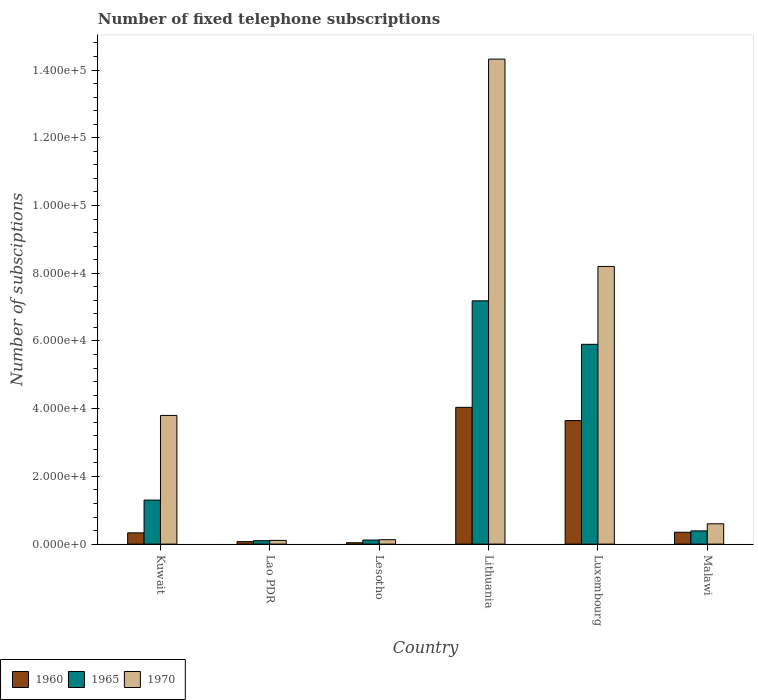How many different coloured bars are there?
Provide a short and direct response. 3. Are the number of bars per tick equal to the number of legend labels?
Your answer should be very brief. Yes. Are the number of bars on each tick of the X-axis equal?
Ensure brevity in your answer.  Yes. How many bars are there on the 6th tick from the right?
Offer a very short reply. 3. What is the label of the 3rd group of bars from the left?
Offer a terse response. Lesotho. What is the number of fixed telephone subscriptions in 1965 in Lao PDR?
Ensure brevity in your answer.  1000. Across all countries, what is the maximum number of fixed telephone subscriptions in 1970?
Your answer should be compact. 1.43e+05. Across all countries, what is the minimum number of fixed telephone subscriptions in 1960?
Ensure brevity in your answer.  400. In which country was the number of fixed telephone subscriptions in 1960 maximum?
Keep it short and to the point. Lithuania. In which country was the number of fixed telephone subscriptions in 1960 minimum?
Offer a terse response. Lesotho. What is the total number of fixed telephone subscriptions in 1960 in the graph?
Give a very brief answer. 8.48e+04. What is the difference between the number of fixed telephone subscriptions in 1960 in Kuwait and that in Malawi?
Your answer should be compact. -184. What is the difference between the number of fixed telephone subscriptions in 1960 in Kuwait and the number of fixed telephone subscriptions in 1970 in Lao PDR?
Give a very brief answer. 2216. What is the average number of fixed telephone subscriptions in 1965 per country?
Provide a short and direct response. 2.50e+04. What is the difference between the number of fixed telephone subscriptions of/in 1965 and number of fixed telephone subscriptions of/in 1970 in Luxembourg?
Keep it short and to the point. -2.30e+04. In how many countries, is the number of fixed telephone subscriptions in 1965 greater than 4000?
Offer a terse response. 3. What is the ratio of the number of fixed telephone subscriptions in 1970 in Lao PDR to that in Lithuania?
Ensure brevity in your answer.  0.01. Is the number of fixed telephone subscriptions in 1960 in Kuwait less than that in Lesotho?
Make the answer very short. No. What is the difference between the highest and the second highest number of fixed telephone subscriptions in 1965?
Provide a short and direct response. 4.60e+04. What is the difference between the highest and the lowest number of fixed telephone subscriptions in 1960?
Provide a short and direct response. 4.00e+04. In how many countries, is the number of fixed telephone subscriptions in 1970 greater than the average number of fixed telephone subscriptions in 1970 taken over all countries?
Provide a succinct answer. 2. Is the sum of the number of fixed telephone subscriptions in 1970 in Kuwait and Luxembourg greater than the maximum number of fixed telephone subscriptions in 1960 across all countries?
Make the answer very short. Yes. What does the 2nd bar from the left in Luxembourg represents?
Your response must be concise. 1965. What does the 1st bar from the right in Kuwait represents?
Offer a very short reply. 1970. Is it the case that in every country, the sum of the number of fixed telephone subscriptions in 1970 and number of fixed telephone subscriptions in 1960 is greater than the number of fixed telephone subscriptions in 1965?
Ensure brevity in your answer.  Yes. Are all the bars in the graph horizontal?
Offer a very short reply. No. Are the values on the major ticks of Y-axis written in scientific E-notation?
Offer a terse response. Yes. Does the graph contain any zero values?
Provide a short and direct response. No. Does the graph contain grids?
Your answer should be very brief. No. How many legend labels are there?
Keep it short and to the point. 3. What is the title of the graph?
Your answer should be very brief. Number of fixed telephone subscriptions. Does "2007" appear as one of the legend labels in the graph?
Your response must be concise. No. What is the label or title of the X-axis?
Ensure brevity in your answer.  Country. What is the label or title of the Y-axis?
Offer a terse response. Number of subsciptions. What is the Number of subsciptions of 1960 in Kuwait?
Provide a short and direct response. 3316. What is the Number of subsciptions of 1965 in Kuwait?
Provide a short and direct response. 1.30e+04. What is the Number of subsciptions of 1970 in Kuwait?
Your response must be concise. 3.80e+04. What is the Number of subsciptions of 1960 in Lao PDR?
Offer a very short reply. 736. What is the Number of subsciptions of 1965 in Lao PDR?
Ensure brevity in your answer.  1000. What is the Number of subsciptions in 1970 in Lao PDR?
Provide a succinct answer. 1100. What is the Number of subsciptions in 1960 in Lesotho?
Your response must be concise. 400. What is the Number of subsciptions of 1965 in Lesotho?
Provide a succinct answer. 1200. What is the Number of subsciptions in 1970 in Lesotho?
Ensure brevity in your answer.  1300. What is the Number of subsciptions of 1960 in Lithuania?
Ensure brevity in your answer.  4.04e+04. What is the Number of subsciptions in 1965 in Lithuania?
Offer a terse response. 7.18e+04. What is the Number of subsciptions of 1970 in Lithuania?
Offer a terse response. 1.43e+05. What is the Number of subsciptions in 1960 in Luxembourg?
Offer a very short reply. 3.65e+04. What is the Number of subsciptions in 1965 in Luxembourg?
Ensure brevity in your answer.  5.90e+04. What is the Number of subsciptions of 1970 in Luxembourg?
Your answer should be very brief. 8.20e+04. What is the Number of subsciptions of 1960 in Malawi?
Your answer should be very brief. 3500. What is the Number of subsciptions of 1965 in Malawi?
Offer a very short reply. 3900. What is the Number of subsciptions of 1970 in Malawi?
Your answer should be compact. 6000. Across all countries, what is the maximum Number of subsciptions in 1960?
Provide a succinct answer. 4.04e+04. Across all countries, what is the maximum Number of subsciptions of 1965?
Provide a short and direct response. 7.18e+04. Across all countries, what is the maximum Number of subsciptions of 1970?
Offer a terse response. 1.43e+05. Across all countries, what is the minimum Number of subsciptions in 1965?
Provide a succinct answer. 1000. Across all countries, what is the minimum Number of subsciptions of 1970?
Keep it short and to the point. 1100. What is the total Number of subsciptions in 1960 in the graph?
Your response must be concise. 8.48e+04. What is the total Number of subsciptions in 1965 in the graph?
Give a very brief answer. 1.50e+05. What is the total Number of subsciptions in 1970 in the graph?
Provide a short and direct response. 2.72e+05. What is the difference between the Number of subsciptions of 1960 in Kuwait and that in Lao PDR?
Offer a very short reply. 2580. What is the difference between the Number of subsciptions in 1965 in Kuwait and that in Lao PDR?
Keep it short and to the point. 1.20e+04. What is the difference between the Number of subsciptions of 1970 in Kuwait and that in Lao PDR?
Provide a short and direct response. 3.69e+04. What is the difference between the Number of subsciptions in 1960 in Kuwait and that in Lesotho?
Make the answer very short. 2916. What is the difference between the Number of subsciptions of 1965 in Kuwait and that in Lesotho?
Offer a terse response. 1.18e+04. What is the difference between the Number of subsciptions in 1970 in Kuwait and that in Lesotho?
Offer a very short reply. 3.67e+04. What is the difference between the Number of subsciptions in 1960 in Kuwait and that in Lithuania?
Your response must be concise. -3.71e+04. What is the difference between the Number of subsciptions of 1965 in Kuwait and that in Lithuania?
Ensure brevity in your answer.  -5.88e+04. What is the difference between the Number of subsciptions of 1970 in Kuwait and that in Lithuania?
Offer a very short reply. -1.05e+05. What is the difference between the Number of subsciptions of 1960 in Kuwait and that in Luxembourg?
Your response must be concise. -3.32e+04. What is the difference between the Number of subsciptions of 1965 in Kuwait and that in Luxembourg?
Give a very brief answer. -4.60e+04. What is the difference between the Number of subsciptions in 1970 in Kuwait and that in Luxembourg?
Ensure brevity in your answer.  -4.40e+04. What is the difference between the Number of subsciptions in 1960 in Kuwait and that in Malawi?
Provide a succinct answer. -184. What is the difference between the Number of subsciptions in 1965 in Kuwait and that in Malawi?
Keep it short and to the point. 9100. What is the difference between the Number of subsciptions in 1970 in Kuwait and that in Malawi?
Offer a terse response. 3.20e+04. What is the difference between the Number of subsciptions in 1960 in Lao PDR and that in Lesotho?
Your response must be concise. 336. What is the difference between the Number of subsciptions of 1965 in Lao PDR and that in Lesotho?
Make the answer very short. -200. What is the difference between the Number of subsciptions in 1970 in Lao PDR and that in Lesotho?
Give a very brief answer. -200. What is the difference between the Number of subsciptions in 1960 in Lao PDR and that in Lithuania?
Your response must be concise. -3.97e+04. What is the difference between the Number of subsciptions of 1965 in Lao PDR and that in Lithuania?
Offer a terse response. -7.08e+04. What is the difference between the Number of subsciptions of 1970 in Lao PDR and that in Lithuania?
Your response must be concise. -1.42e+05. What is the difference between the Number of subsciptions of 1960 in Lao PDR and that in Luxembourg?
Keep it short and to the point. -3.58e+04. What is the difference between the Number of subsciptions of 1965 in Lao PDR and that in Luxembourg?
Your answer should be very brief. -5.80e+04. What is the difference between the Number of subsciptions in 1970 in Lao PDR and that in Luxembourg?
Your response must be concise. -8.09e+04. What is the difference between the Number of subsciptions of 1960 in Lao PDR and that in Malawi?
Give a very brief answer. -2764. What is the difference between the Number of subsciptions of 1965 in Lao PDR and that in Malawi?
Provide a succinct answer. -2900. What is the difference between the Number of subsciptions in 1970 in Lao PDR and that in Malawi?
Make the answer very short. -4900. What is the difference between the Number of subsciptions in 1960 in Lesotho and that in Lithuania?
Offer a very short reply. -4.00e+04. What is the difference between the Number of subsciptions of 1965 in Lesotho and that in Lithuania?
Your answer should be very brief. -7.06e+04. What is the difference between the Number of subsciptions of 1970 in Lesotho and that in Lithuania?
Your response must be concise. -1.42e+05. What is the difference between the Number of subsciptions of 1960 in Lesotho and that in Luxembourg?
Provide a succinct answer. -3.61e+04. What is the difference between the Number of subsciptions in 1965 in Lesotho and that in Luxembourg?
Keep it short and to the point. -5.78e+04. What is the difference between the Number of subsciptions in 1970 in Lesotho and that in Luxembourg?
Provide a succinct answer. -8.07e+04. What is the difference between the Number of subsciptions of 1960 in Lesotho and that in Malawi?
Your answer should be compact. -3100. What is the difference between the Number of subsciptions in 1965 in Lesotho and that in Malawi?
Your response must be concise. -2700. What is the difference between the Number of subsciptions of 1970 in Lesotho and that in Malawi?
Make the answer very short. -4700. What is the difference between the Number of subsciptions in 1960 in Lithuania and that in Luxembourg?
Your answer should be very brief. 3902. What is the difference between the Number of subsciptions of 1965 in Lithuania and that in Luxembourg?
Your response must be concise. 1.28e+04. What is the difference between the Number of subsciptions in 1970 in Lithuania and that in Luxembourg?
Offer a terse response. 6.12e+04. What is the difference between the Number of subsciptions of 1960 in Lithuania and that in Malawi?
Make the answer very short. 3.69e+04. What is the difference between the Number of subsciptions in 1965 in Lithuania and that in Malawi?
Your response must be concise. 6.79e+04. What is the difference between the Number of subsciptions in 1970 in Lithuania and that in Malawi?
Ensure brevity in your answer.  1.37e+05. What is the difference between the Number of subsciptions in 1960 in Luxembourg and that in Malawi?
Offer a very short reply. 3.30e+04. What is the difference between the Number of subsciptions in 1965 in Luxembourg and that in Malawi?
Provide a succinct answer. 5.51e+04. What is the difference between the Number of subsciptions of 1970 in Luxembourg and that in Malawi?
Provide a short and direct response. 7.60e+04. What is the difference between the Number of subsciptions of 1960 in Kuwait and the Number of subsciptions of 1965 in Lao PDR?
Your answer should be very brief. 2316. What is the difference between the Number of subsciptions in 1960 in Kuwait and the Number of subsciptions in 1970 in Lao PDR?
Ensure brevity in your answer.  2216. What is the difference between the Number of subsciptions of 1965 in Kuwait and the Number of subsciptions of 1970 in Lao PDR?
Your answer should be very brief. 1.19e+04. What is the difference between the Number of subsciptions in 1960 in Kuwait and the Number of subsciptions in 1965 in Lesotho?
Your response must be concise. 2116. What is the difference between the Number of subsciptions in 1960 in Kuwait and the Number of subsciptions in 1970 in Lesotho?
Keep it short and to the point. 2016. What is the difference between the Number of subsciptions in 1965 in Kuwait and the Number of subsciptions in 1970 in Lesotho?
Offer a very short reply. 1.17e+04. What is the difference between the Number of subsciptions of 1960 in Kuwait and the Number of subsciptions of 1965 in Lithuania?
Provide a succinct answer. -6.85e+04. What is the difference between the Number of subsciptions of 1960 in Kuwait and the Number of subsciptions of 1970 in Lithuania?
Make the answer very short. -1.40e+05. What is the difference between the Number of subsciptions in 1965 in Kuwait and the Number of subsciptions in 1970 in Lithuania?
Offer a terse response. -1.30e+05. What is the difference between the Number of subsciptions in 1960 in Kuwait and the Number of subsciptions in 1965 in Luxembourg?
Make the answer very short. -5.57e+04. What is the difference between the Number of subsciptions of 1960 in Kuwait and the Number of subsciptions of 1970 in Luxembourg?
Provide a short and direct response. -7.87e+04. What is the difference between the Number of subsciptions of 1965 in Kuwait and the Number of subsciptions of 1970 in Luxembourg?
Your answer should be compact. -6.90e+04. What is the difference between the Number of subsciptions of 1960 in Kuwait and the Number of subsciptions of 1965 in Malawi?
Give a very brief answer. -584. What is the difference between the Number of subsciptions of 1960 in Kuwait and the Number of subsciptions of 1970 in Malawi?
Offer a terse response. -2684. What is the difference between the Number of subsciptions in 1965 in Kuwait and the Number of subsciptions in 1970 in Malawi?
Offer a terse response. 7000. What is the difference between the Number of subsciptions of 1960 in Lao PDR and the Number of subsciptions of 1965 in Lesotho?
Offer a very short reply. -464. What is the difference between the Number of subsciptions of 1960 in Lao PDR and the Number of subsciptions of 1970 in Lesotho?
Your response must be concise. -564. What is the difference between the Number of subsciptions of 1965 in Lao PDR and the Number of subsciptions of 1970 in Lesotho?
Ensure brevity in your answer.  -300. What is the difference between the Number of subsciptions of 1960 in Lao PDR and the Number of subsciptions of 1965 in Lithuania?
Offer a terse response. -7.11e+04. What is the difference between the Number of subsciptions in 1960 in Lao PDR and the Number of subsciptions in 1970 in Lithuania?
Keep it short and to the point. -1.42e+05. What is the difference between the Number of subsciptions in 1965 in Lao PDR and the Number of subsciptions in 1970 in Lithuania?
Your answer should be compact. -1.42e+05. What is the difference between the Number of subsciptions in 1960 in Lao PDR and the Number of subsciptions in 1965 in Luxembourg?
Offer a very short reply. -5.83e+04. What is the difference between the Number of subsciptions in 1960 in Lao PDR and the Number of subsciptions in 1970 in Luxembourg?
Provide a succinct answer. -8.13e+04. What is the difference between the Number of subsciptions of 1965 in Lao PDR and the Number of subsciptions of 1970 in Luxembourg?
Your answer should be very brief. -8.10e+04. What is the difference between the Number of subsciptions of 1960 in Lao PDR and the Number of subsciptions of 1965 in Malawi?
Give a very brief answer. -3164. What is the difference between the Number of subsciptions of 1960 in Lao PDR and the Number of subsciptions of 1970 in Malawi?
Give a very brief answer. -5264. What is the difference between the Number of subsciptions in 1965 in Lao PDR and the Number of subsciptions in 1970 in Malawi?
Your response must be concise. -5000. What is the difference between the Number of subsciptions of 1960 in Lesotho and the Number of subsciptions of 1965 in Lithuania?
Keep it short and to the point. -7.14e+04. What is the difference between the Number of subsciptions of 1960 in Lesotho and the Number of subsciptions of 1970 in Lithuania?
Ensure brevity in your answer.  -1.43e+05. What is the difference between the Number of subsciptions in 1965 in Lesotho and the Number of subsciptions in 1970 in Lithuania?
Your answer should be compact. -1.42e+05. What is the difference between the Number of subsciptions of 1960 in Lesotho and the Number of subsciptions of 1965 in Luxembourg?
Ensure brevity in your answer.  -5.86e+04. What is the difference between the Number of subsciptions in 1960 in Lesotho and the Number of subsciptions in 1970 in Luxembourg?
Give a very brief answer. -8.16e+04. What is the difference between the Number of subsciptions in 1965 in Lesotho and the Number of subsciptions in 1970 in Luxembourg?
Ensure brevity in your answer.  -8.08e+04. What is the difference between the Number of subsciptions in 1960 in Lesotho and the Number of subsciptions in 1965 in Malawi?
Make the answer very short. -3500. What is the difference between the Number of subsciptions of 1960 in Lesotho and the Number of subsciptions of 1970 in Malawi?
Make the answer very short. -5600. What is the difference between the Number of subsciptions of 1965 in Lesotho and the Number of subsciptions of 1970 in Malawi?
Make the answer very short. -4800. What is the difference between the Number of subsciptions of 1960 in Lithuania and the Number of subsciptions of 1965 in Luxembourg?
Your answer should be compact. -1.86e+04. What is the difference between the Number of subsciptions in 1960 in Lithuania and the Number of subsciptions in 1970 in Luxembourg?
Your answer should be compact. -4.16e+04. What is the difference between the Number of subsciptions of 1965 in Lithuania and the Number of subsciptions of 1970 in Luxembourg?
Your answer should be compact. -1.02e+04. What is the difference between the Number of subsciptions of 1960 in Lithuania and the Number of subsciptions of 1965 in Malawi?
Give a very brief answer. 3.65e+04. What is the difference between the Number of subsciptions of 1960 in Lithuania and the Number of subsciptions of 1970 in Malawi?
Make the answer very short. 3.44e+04. What is the difference between the Number of subsciptions of 1965 in Lithuania and the Number of subsciptions of 1970 in Malawi?
Make the answer very short. 6.58e+04. What is the difference between the Number of subsciptions of 1960 in Luxembourg and the Number of subsciptions of 1965 in Malawi?
Provide a short and direct response. 3.26e+04. What is the difference between the Number of subsciptions of 1960 in Luxembourg and the Number of subsciptions of 1970 in Malawi?
Your answer should be very brief. 3.05e+04. What is the difference between the Number of subsciptions of 1965 in Luxembourg and the Number of subsciptions of 1970 in Malawi?
Ensure brevity in your answer.  5.30e+04. What is the average Number of subsciptions of 1960 per country?
Your answer should be compact. 1.41e+04. What is the average Number of subsciptions in 1965 per country?
Offer a terse response. 2.50e+04. What is the average Number of subsciptions of 1970 per country?
Ensure brevity in your answer.  4.53e+04. What is the difference between the Number of subsciptions in 1960 and Number of subsciptions in 1965 in Kuwait?
Your answer should be compact. -9684. What is the difference between the Number of subsciptions of 1960 and Number of subsciptions of 1970 in Kuwait?
Offer a terse response. -3.47e+04. What is the difference between the Number of subsciptions in 1965 and Number of subsciptions in 1970 in Kuwait?
Give a very brief answer. -2.50e+04. What is the difference between the Number of subsciptions in 1960 and Number of subsciptions in 1965 in Lao PDR?
Your answer should be compact. -264. What is the difference between the Number of subsciptions of 1960 and Number of subsciptions of 1970 in Lao PDR?
Provide a succinct answer. -364. What is the difference between the Number of subsciptions in 1965 and Number of subsciptions in 1970 in Lao PDR?
Your answer should be compact. -100. What is the difference between the Number of subsciptions of 1960 and Number of subsciptions of 1965 in Lesotho?
Your answer should be very brief. -800. What is the difference between the Number of subsciptions of 1960 and Number of subsciptions of 1970 in Lesotho?
Your answer should be very brief. -900. What is the difference between the Number of subsciptions in 1965 and Number of subsciptions in 1970 in Lesotho?
Keep it short and to the point. -100. What is the difference between the Number of subsciptions of 1960 and Number of subsciptions of 1965 in Lithuania?
Provide a succinct answer. -3.15e+04. What is the difference between the Number of subsciptions of 1960 and Number of subsciptions of 1970 in Lithuania?
Your answer should be compact. -1.03e+05. What is the difference between the Number of subsciptions of 1965 and Number of subsciptions of 1970 in Lithuania?
Keep it short and to the point. -7.14e+04. What is the difference between the Number of subsciptions in 1960 and Number of subsciptions in 1965 in Luxembourg?
Your answer should be compact. -2.25e+04. What is the difference between the Number of subsciptions in 1960 and Number of subsciptions in 1970 in Luxembourg?
Provide a succinct answer. -4.55e+04. What is the difference between the Number of subsciptions in 1965 and Number of subsciptions in 1970 in Luxembourg?
Your response must be concise. -2.30e+04. What is the difference between the Number of subsciptions in 1960 and Number of subsciptions in 1965 in Malawi?
Keep it short and to the point. -400. What is the difference between the Number of subsciptions in 1960 and Number of subsciptions in 1970 in Malawi?
Give a very brief answer. -2500. What is the difference between the Number of subsciptions in 1965 and Number of subsciptions in 1970 in Malawi?
Offer a terse response. -2100. What is the ratio of the Number of subsciptions in 1960 in Kuwait to that in Lao PDR?
Your answer should be very brief. 4.51. What is the ratio of the Number of subsciptions in 1970 in Kuwait to that in Lao PDR?
Your response must be concise. 34.55. What is the ratio of the Number of subsciptions of 1960 in Kuwait to that in Lesotho?
Offer a very short reply. 8.29. What is the ratio of the Number of subsciptions in 1965 in Kuwait to that in Lesotho?
Provide a succinct answer. 10.83. What is the ratio of the Number of subsciptions of 1970 in Kuwait to that in Lesotho?
Ensure brevity in your answer.  29.23. What is the ratio of the Number of subsciptions in 1960 in Kuwait to that in Lithuania?
Your response must be concise. 0.08. What is the ratio of the Number of subsciptions in 1965 in Kuwait to that in Lithuania?
Ensure brevity in your answer.  0.18. What is the ratio of the Number of subsciptions of 1970 in Kuwait to that in Lithuania?
Ensure brevity in your answer.  0.27. What is the ratio of the Number of subsciptions in 1960 in Kuwait to that in Luxembourg?
Provide a succinct answer. 0.09. What is the ratio of the Number of subsciptions in 1965 in Kuwait to that in Luxembourg?
Your response must be concise. 0.22. What is the ratio of the Number of subsciptions of 1970 in Kuwait to that in Luxembourg?
Keep it short and to the point. 0.46. What is the ratio of the Number of subsciptions of 1960 in Kuwait to that in Malawi?
Offer a very short reply. 0.95. What is the ratio of the Number of subsciptions in 1970 in Kuwait to that in Malawi?
Ensure brevity in your answer.  6.33. What is the ratio of the Number of subsciptions in 1960 in Lao PDR to that in Lesotho?
Your response must be concise. 1.84. What is the ratio of the Number of subsciptions in 1965 in Lao PDR to that in Lesotho?
Keep it short and to the point. 0.83. What is the ratio of the Number of subsciptions in 1970 in Lao PDR to that in Lesotho?
Your response must be concise. 0.85. What is the ratio of the Number of subsciptions in 1960 in Lao PDR to that in Lithuania?
Make the answer very short. 0.02. What is the ratio of the Number of subsciptions of 1965 in Lao PDR to that in Lithuania?
Keep it short and to the point. 0.01. What is the ratio of the Number of subsciptions in 1970 in Lao PDR to that in Lithuania?
Ensure brevity in your answer.  0.01. What is the ratio of the Number of subsciptions in 1960 in Lao PDR to that in Luxembourg?
Keep it short and to the point. 0.02. What is the ratio of the Number of subsciptions of 1965 in Lao PDR to that in Luxembourg?
Offer a very short reply. 0.02. What is the ratio of the Number of subsciptions of 1970 in Lao PDR to that in Luxembourg?
Your response must be concise. 0.01. What is the ratio of the Number of subsciptions in 1960 in Lao PDR to that in Malawi?
Offer a very short reply. 0.21. What is the ratio of the Number of subsciptions of 1965 in Lao PDR to that in Malawi?
Make the answer very short. 0.26. What is the ratio of the Number of subsciptions in 1970 in Lao PDR to that in Malawi?
Offer a very short reply. 0.18. What is the ratio of the Number of subsciptions of 1960 in Lesotho to that in Lithuania?
Your answer should be very brief. 0.01. What is the ratio of the Number of subsciptions of 1965 in Lesotho to that in Lithuania?
Provide a short and direct response. 0.02. What is the ratio of the Number of subsciptions of 1970 in Lesotho to that in Lithuania?
Your answer should be compact. 0.01. What is the ratio of the Number of subsciptions of 1960 in Lesotho to that in Luxembourg?
Provide a short and direct response. 0.01. What is the ratio of the Number of subsciptions in 1965 in Lesotho to that in Luxembourg?
Your response must be concise. 0.02. What is the ratio of the Number of subsciptions in 1970 in Lesotho to that in Luxembourg?
Offer a very short reply. 0.02. What is the ratio of the Number of subsciptions in 1960 in Lesotho to that in Malawi?
Your response must be concise. 0.11. What is the ratio of the Number of subsciptions of 1965 in Lesotho to that in Malawi?
Provide a succinct answer. 0.31. What is the ratio of the Number of subsciptions of 1970 in Lesotho to that in Malawi?
Offer a very short reply. 0.22. What is the ratio of the Number of subsciptions of 1960 in Lithuania to that in Luxembourg?
Your response must be concise. 1.11. What is the ratio of the Number of subsciptions of 1965 in Lithuania to that in Luxembourg?
Ensure brevity in your answer.  1.22. What is the ratio of the Number of subsciptions in 1970 in Lithuania to that in Luxembourg?
Your response must be concise. 1.75. What is the ratio of the Number of subsciptions of 1960 in Lithuania to that in Malawi?
Make the answer very short. 11.54. What is the ratio of the Number of subsciptions of 1965 in Lithuania to that in Malawi?
Your answer should be compact. 18.42. What is the ratio of the Number of subsciptions in 1970 in Lithuania to that in Malawi?
Provide a succinct answer. 23.87. What is the ratio of the Number of subsciptions of 1960 in Luxembourg to that in Malawi?
Give a very brief answer. 10.42. What is the ratio of the Number of subsciptions of 1965 in Luxembourg to that in Malawi?
Provide a succinct answer. 15.13. What is the ratio of the Number of subsciptions of 1970 in Luxembourg to that in Malawi?
Your answer should be compact. 13.67. What is the difference between the highest and the second highest Number of subsciptions of 1960?
Make the answer very short. 3902. What is the difference between the highest and the second highest Number of subsciptions of 1965?
Ensure brevity in your answer.  1.28e+04. What is the difference between the highest and the second highest Number of subsciptions in 1970?
Your response must be concise. 6.12e+04. What is the difference between the highest and the lowest Number of subsciptions of 1960?
Provide a succinct answer. 4.00e+04. What is the difference between the highest and the lowest Number of subsciptions of 1965?
Give a very brief answer. 7.08e+04. What is the difference between the highest and the lowest Number of subsciptions in 1970?
Offer a very short reply. 1.42e+05. 